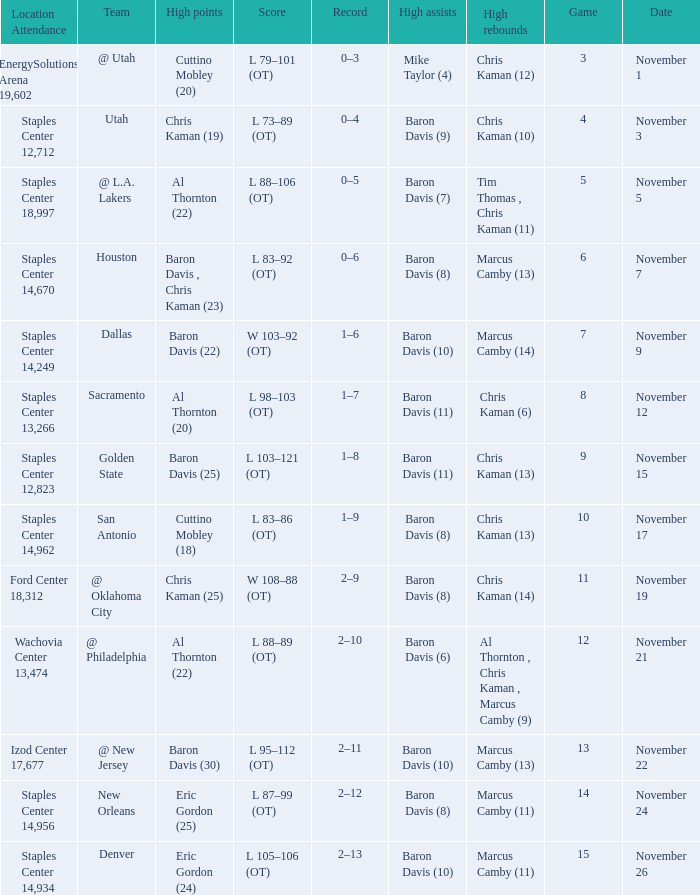Name the total number of score for staples center 13,266 1.0. 